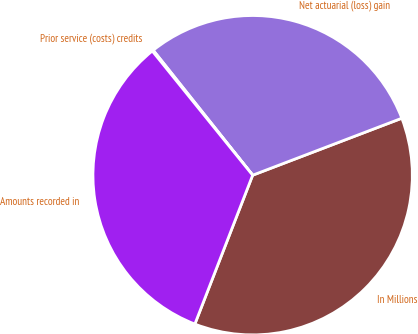Convert chart to OTSL. <chart><loc_0><loc_0><loc_500><loc_500><pie_chart><fcel>In Millions<fcel>Net actuarial (loss) gain<fcel>Prior service (costs) credits<fcel>Amounts recorded in<nl><fcel>36.7%<fcel>29.89%<fcel>0.12%<fcel>33.29%<nl></chart> 